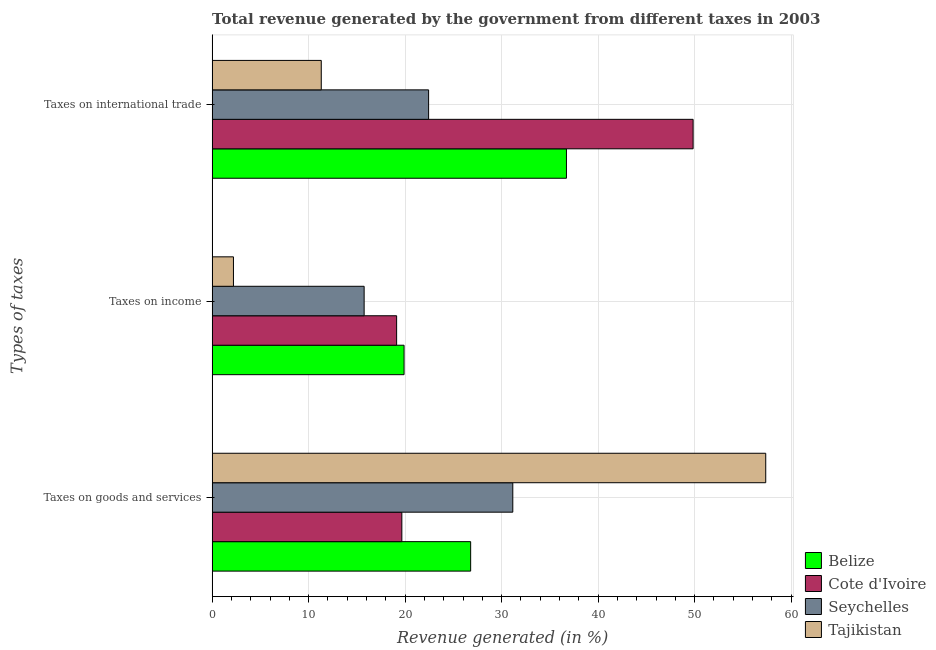How many groups of bars are there?
Your response must be concise. 3. Are the number of bars per tick equal to the number of legend labels?
Provide a succinct answer. Yes. How many bars are there on the 1st tick from the top?
Make the answer very short. 4. What is the label of the 2nd group of bars from the top?
Offer a very short reply. Taxes on income. What is the percentage of revenue generated by taxes on goods and services in Tajikistan?
Offer a very short reply. 57.37. Across all countries, what is the maximum percentage of revenue generated by taxes on goods and services?
Your response must be concise. 57.37. Across all countries, what is the minimum percentage of revenue generated by tax on international trade?
Your answer should be compact. 11.31. In which country was the percentage of revenue generated by tax on international trade maximum?
Make the answer very short. Cote d'Ivoire. In which country was the percentage of revenue generated by tax on international trade minimum?
Offer a terse response. Tajikistan. What is the total percentage of revenue generated by taxes on income in the graph?
Provide a succinct answer. 56.97. What is the difference between the percentage of revenue generated by taxes on goods and services in Belize and that in Tajikistan?
Provide a short and direct response. -30.58. What is the difference between the percentage of revenue generated by tax on international trade in Cote d'Ivoire and the percentage of revenue generated by taxes on income in Tajikistan?
Give a very brief answer. 47.64. What is the average percentage of revenue generated by taxes on goods and services per country?
Your answer should be very brief. 33.75. What is the difference between the percentage of revenue generated by taxes on goods and services and percentage of revenue generated by taxes on income in Cote d'Ivoire?
Your answer should be very brief. 0.54. What is the ratio of the percentage of revenue generated by taxes on income in Seychelles to that in Belize?
Give a very brief answer. 0.79. Is the percentage of revenue generated by taxes on income in Seychelles less than that in Tajikistan?
Keep it short and to the point. No. What is the difference between the highest and the second highest percentage of revenue generated by taxes on goods and services?
Provide a short and direct response. 26.21. What is the difference between the highest and the lowest percentage of revenue generated by tax on international trade?
Offer a terse response. 38.54. What does the 1st bar from the top in Taxes on international trade represents?
Your answer should be very brief. Tajikistan. What does the 4th bar from the bottom in Taxes on income represents?
Keep it short and to the point. Tajikistan. Is it the case that in every country, the sum of the percentage of revenue generated by taxes on goods and services and percentage of revenue generated by taxes on income is greater than the percentage of revenue generated by tax on international trade?
Your answer should be compact. No. Are all the bars in the graph horizontal?
Keep it short and to the point. Yes. What is the difference between two consecutive major ticks on the X-axis?
Your answer should be compact. 10. Are the values on the major ticks of X-axis written in scientific E-notation?
Provide a short and direct response. No. Does the graph contain any zero values?
Your response must be concise. No. Does the graph contain grids?
Make the answer very short. Yes. How many legend labels are there?
Ensure brevity in your answer.  4. How are the legend labels stacked?
Your answer should be compact. Vertical. What is the title of the graph?
Provide a short and direct response. Total revenue generated by the government from different taxes in 2003. Does "Latin America(developing only)" appear as one of the legend labels in the graph?
Your response must be concise. No. What is the label or title of the X-axis?
Offer a terse response. Revenue generated (in %). What is the label or title of the Y-axis?
Offer a very short reply. Types of taxes. What is the Revenue generated (in %) of Belize in Taxes on goods and services?
Provide a succinct answer. 26.79. What is the Revenue generated (in %) of Cote d'Ivoire in Taxes on goods and services?
Your answer should be very brief. 19.66. What is the Revenue generated (in %) of Seychelles in Taxes on goods and services?
Keep it short and to the point. 31.16. What is the Revenue generated (in %) in Tajikistan in Taxes on goods and services?
Your answer should be very brief. 57.37. What is the Revenue generated (in %) of Belize in Taxes on income?
Keep it short and to the point. 19.89. What is the Revenue generated (in %) in Cote d'Ivoire in Taxes on income?
Your answer should be very brief. 19.12. What is the Revenue generated (in %) in Seychelles in Taxes on income?
Your response must be concise. 15.75. What is the Revenue generated (in %) in Tajikistan in Taxes on income?
Your answer should be very brief. 2.21. What is the Revenue generated (in %) of Belize in Taxes on international trade?
Offer a very short reply. 36.72. What is the Revenue generated (in %) in Cote d'Ivoire in Taxes on international trade?
Provide a short and direct response. 49.85. What is the Revenue generated (in %) in Seychelles in Taxes on international trade?
Give a very brief answer. 22.43. What is the Revenue generated (in %) of Tajikistan in Taxes on international trade?
Make the answer very short. 11.31. Across all Types of taxes, what is the maximum Revenue generated (in %) of Belize?
Give a very brief answer. 36.72. Across all Types of taxes, what is the maximum Revenue generated (in %) of Cote d'Ivoire?
Make the answer very short. 49.85. Across all Types of taxes, what is the maximum Revenue generated (in %) of Seychelles?
Ensure brevity in your answer.  31.16. Across all Types of taxes, what is the maximum Revenue generated (in %) in Tajikistan?
Your response must be concise. 57.37. Across all Types of taxes, what is the minimum Revenue generated (in %) in Belize?
Your answer should be compact. 19.89. Across all Types of taxes, what is the minimum Revenue generated (in %) of Cote d'Ivoire?
Make the answer very short. 19.12. Across all Types of taxes, what is the minimum Revenue generated (in %) of Seychelles?
Your response must be concise. 15.75. Across all Types of taxes, what is the minimum Revenue generated (in %) of Tajikistan?
Your answer should be compact. 2.21. What is the total Revenue generated (in %) in Belize in the graph?
Your answer should be compact. 83.4. What is the total Revenue generated (in %) of Cote d'Ivoire in the graph?
Provide a succinct answer. 88.63. What is the total Revenue generated (in %) in Seychelles in the graph?
Offer a terse response. 69.35. What is the total Revenue generated (in %) of Tajikistan in the graph?
Your answer should be compact. 70.89. What is the difference between the Revenue generated (in %) in Belize in Taxes on goods and services and that in Taxes on income?
Provide a short and direct response. 6.9. What is the difference between the Revenue generated (in %) of Cote d'Ivoire in Taxes on goods and services and that in Taxes on income?
Your answer should be compact. 0.54. What is the difference between the Revenue generated (in %) in Seychelles in Taxes on goods and services and that in Taxes on income?
Offer a terse response. 15.41. What is the difference between the Revenue generated (in %) in Tajikistan in Taxes on goods and services and that in Taxes on income?
Keep it short and to the point. 55.16. What is the difference between the Revenue generated (in %) of Belize in Taxes on goods and services and that in Taxes on international trade?
Your answer should be very brief. -9.93. What is the difference between the Revenue generated (in %) in Cote d'Ivoire in Taxes on goods and services and that in Taxes on international trade?
Ensure brevity in your answer.  -30.18. What is the difference between the Revenue generated (in %) of Seychelles in Taxes on goods and services and that in Taxes on international trade?
Your answer should be compact. 8.73. What is the difference between the Revenue generated (in %) of Tajikistan in Taxes on goods and services and that in Taxes on international trade?
Your answer should be very brief. 46.06. What is the difference between the Revenue generated (in %) of Belize in Taxes on income and that in Taxes on international trade?
Your response must be concise. -16.83. What is the difference between the Revenue generated (in %) in Cote d'Ivoire in Taxes on income and that in Taxes on international trade?
Make the answer very short. -30.73. What is the difference between the Revenue generated (in %) of Seychelles in Taxes on income and that in Taxes on international trade?
Offer a terse response. -6.68. What is the difference between the Revenue generated (in %) of Tajikistan in Taxes on income and that in Taxes on international trade?
Ensure brevity in your answer.  -9.1. What is the difference between the Revenue generated (in %) in Belize in Taxes on goods and services and the Revenue generated (in %) in Cote d'Ivoire in Taxes on income?
Your answer should be compact. 7.67. What is the difference between the Revenue generated (in %) of Belize in Taxes on goods and services and the Revenue generated (in %) of Seychelles in Taxes on income?
Offer a very short reply. 11.04. What is the difference between the Revenue generated (in %) of Belize in Taxes on goods and services and the Revenue generated (in %) of Tajikistan in Taxes on income?
Provide a succinct answer. 24.58. What is the difference between the Revenue generated (in %) in Cote d'Ivoire in Taxes on goods and services and the Revenue generated (in %) in Seychelles in Taxes on income?
Make the answer very short. 3.91. What is the difference between the Revenue generated (in %) in Cote d'Ivoire in Taxes on goods and services and the Revenue generated (in %) in Tajikistan in Taxes on income?
Ensure brevity in your answer.  17.45. What is the difference between the Revenue generated (in %) in Seychelles in Taxes on goods and services and the Revenue generated (in %) in Tajikistan in Taxes on income?
Give a very brief answer. 28.95. What is the difference between the Revenue generated (in %) of Belize in Taxes on goods and services and the Revenue generated (in %) of Cote d'Ivoire in Taxes on international trade?
Provide a succinct answer. -23.05. What is the difference between the Revenue generated (in %) in Belize in Taxes on goods and services and the Revenue generated (in %) in Seychelles in Taxes on international trade?
Provide a succinct answer. 4.36. What is the difference between the Revenue generated (in %) of Belize in Taxes on goods and services and the Revenue generated (in %) of Tajikistan in Taxes on international trade?
Your answer should be very brief. 15.48. What is the difference between the Revenue generated (in %) in Cote d'Ivoire in Taxes on goods and services and the Revenue generated (in %) in Seychelles in Taxes on international trade?
Make the answer very short. -2.77. What is the difference between the Revenue generated (in %) of Cote d'Ivoire in Taxes on goods and services and the Revenue generated (in %) of Tajikistan in Taxes on international trade?
Offer a very short reply. 8.35. What is the difference between the Revenue generated (in %) in Seychelles in Taxes on goods and services and the Revenue generated (in %) in Tajikistan in Taxes on international trade?
Offer a very short reply. 19.85. What is the difference between the Revenue generated (in %) of Belize in Taxes on income and the Revenue generated (in %) of Cote d'Ivoire in Taxes on international trade?
Offer a very short reply. -29.95. What is the difference between the Revenue generated (in %) in Belize in Taxes on income and the Revenue generated (in %) in Seychelles in Taxes on international trade?
Your response must be concise. -2.54. What is the difference between the Revenue generated (in %) of Belize in Taxes on income and the Revenue generated (in %) of Tajikistan in Taxes on international trade?
Your response must be concise. 8.58. What is the difference between the Revenue generated (in %) of Cote d'Ivoire in Taxes on income and the Revenue generated (in %) of Seychelles in Taxes on international trade?
Offer a terse response. -3.31. What is the difference between the Revenue generated (in %) in Cote d'Ivoire in Taxes on income and the Revenue generated (in %) in Tajikistan in Taxes on international trade?
Provide a short and direct response. 7.81. What is the difference between the Revenue generated (in %) in Seychelles in Taxes on income and the Revenue generated (in %) in Tajikistan in Taxes on international trade?
Make the answer very short. 4.44. What is the average Revenue generated (in %) of Belize per Types of taxes?
Provide a succinct answer. 27.8. What is the average Revenue generated (in %) of Cote d'Ivoire per Types of taxes?
Ensure brevity in your answer.  29.54. What is the average Revenue generated (in %) in Seychelles per Types of taxes?
Make the answer very short. 23.12. What is the average Revenue generated (in %) of Tajikistan per Types of taxes?
Ensure brevity in your answer.  23.63. What is the difference between the Revenue generated (in %) in Belize and Revenue generated (in %) in Cote d'Ivoire in Taxes on goods and services?
Offer a terse response. 7.13. What is the difference between the Revenue generated (in %) of Belize and Revenue generated (in %) of Seychelles in Taxes on goods and services?
Keep it short and to the point. -4.37. What is the difference between the Revenue generated (in %) in Belize and Revenue generated (in %) in Tajikistan in Taxes on goods and services?
Give a very brief answer. -30.58. What is the difference between the Revenue generated (in %) in Cote d'Ivoire and Revenue generated (in %) in Seychelles in Taxes on goods and services?
Offer a terse response. -11.5. What is the difference between the Revenue generated (in %) in Cote d'Ivoire and Revenue generated (in %) in Tajikistan in Taxes on goods and services?
Provide a short and direct response. -37.71. What is the difference between the Revenue generated (in %) in Seychelles and Revenue generated (in %) in Tajikistan in Taxes on goods and services?
Your answer should be compact. -26.21. What is the difference between the Revenue generated (in %) in Belize and Revenue generated (in %) in Cote d'Ivoire in Taxes on income?
Make the answer very short. 0.77. What is the difference between the Revenue generated (in %) in Belize and Revenue generated (in %) in Seychelles in Taxes on income?
Make the answer very short. 4.14. What is the difference between the Revenue generated (in %) in Belize and Revenue generated (in %) in Tajikistan in Taxes on income?
Provide a short and direct response. 17.68. What is the difference between the Revenue generated (in %) in Cote d'Ivoire and Revenue generated (in %) in Seychelles in Taxes on income?
Keep it short and to the point. 3.37. What is the difference between the Revenue generated (in %) of Cote d'Ivoire and Revenue generated (in %) of Tajikistan in Taxes on income?
Make the answer very short. 16.91. What is the difference between the Revenue generated (in %) of Seychelles and Revenue generated (in %) of Tajikistan in Taxes on income?
Offer a terse response. 13.54. What is the difference between the Revenue generated (in %) in Belize and Revenue generated (in %) in Cote d'Ivoire in Taxes on international trade?
Provide a short and direct response. -13.13. What is the difference between the Revenue generated (in %) in Belize and Revenue generated (in %) in Seychelles in Taxes on international trade?
Provide a succinct answer. 14.29. What is the difference between the Revenue generated (in %) in Belize and Revenue generated (in %) in Tajikistan in Taxes on international trade?
Your response must be concise. 25.41. What is the difference between the Revenue generated (in %) in Cote d'Ivoire and Revenue generated (in %) in Seychelles in Taxes on international trade?
Keep it short and to the point. 27.41. What is the difference between the Revenue generated (in %) of Cote d'Ivoire and Revenue generated (in %) of Tajikistan in Taxes on international trade?
Your answer should be very brief. 38.53. What is the difference between the Revenue generated (in %) of Seychelles and Revenue generated (in %) of Tajikistan in Taxes on international trade?
Give a very brief answer. 11.12. What is the ratio of the Revenue generated (in %) of Belize in Taxes on goods and services to that in Taxes on income?
Your response must be concise. 1.35. What is the ratio of the Revenue generated (in %) of Cote d'Ivoire in Taxes on goods and services to that in Taxes on income?
Give a very brief answer. 1.03. What is the ratio of the Revenue generated (in %) of Seychelles in Taxes on goods and services to that in Taxes on income?
Offer a terse response. 1.98. What is the ratio of the Revenue generated (in %) in Tajikistan in Taxes on goods and services to that in Taxes on income?
Ensure brevity in your answer.  25.96. What is the ratio of the Revenue generated (in %) of Belize in Taxes on goods and services to that in Taxes on international trade?
Keep it short and to the point. 0.73. What is the ratio of the Revenue generated (in %) of Cote d'Ivoire in Taxes on goods and services to that in Taxes on international trade?
Keep it short and to the point. 0.39. What is the ratio of the Revenue generated (in %) in Seychelles in Taxes on goods and services to that in Taxes on international trade?
Keep it short and to the point. 1.39. What is the ratio of the Revenue generated (in %) in Tajikistan in Taxes on goods and services to that in Taxes on international trade?
Provide a short and direct response. 5.07. What is the ratio of the Revenue generated (in %) in Belize in Taxes on income to that in Taxes on international trade?
Offer a terse response. 0.54. What is the ratio of the Revenue generated (in %) of Cote d'Ivoire in Taxes on income to that in Taxes on international trade?
Ensure brevity in your answer.  0.38. What is the ratio of the Revenue generated (in %) in Seychelles in Taxes on income to that in Taxes on international trade?
Ensure brevity in your answer.  0.7. What is the ratio of the Revenue generated (in %) in Tajikistan in Taxes on income to that in Taxes on international trade?
Provide a short and direct response. 0.2. What is the difference between the highest and the second highest Revenue generated (in %) of Belize?
Give a very brief answer. 9.93. What is the difference between the highest and the second highest Revenue generated (in %) in Cote d'Ivoire?
Offer a very short reply. 30.18. What is the difference between the highest and the second highest Revenue generated (in %) of Seychelles?
Provide a succinct answer. 8.73. What is the difference between the highest and the second highest Revenue generated (in %) of Tajikistan?
Your response must be concise. 46.06. What is the difference between the highest and the lowest Revenue generated (in %) in Belize?
Provide a succinct answer. 16.83. What is the difference between the highest and the lowest Revenue generated (in %) in Cote d'Ivoire?
Ensure brevity in your answer.  30.73. What is the difference between the highest and the lowest Revenue generated (in %) of Seychelles?
Your answer should be very brief. 15.41. What is the difference between the highest and the lowest Revenue generated (in %) of Tajikistan?
Provide a succinct answer. 55.16. 